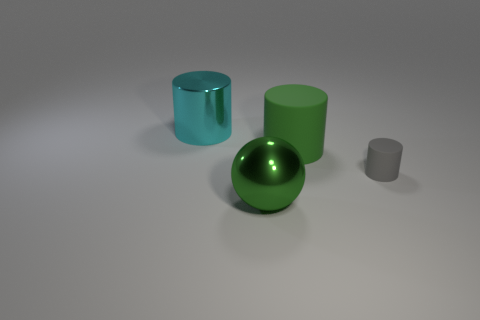Subtract all shiny cylinders. How many cylinders are left? 2 Add 2 big purple cylinders. How many objects exist? 6 Subtract all cylinders. How many objects are left? 1 Add 1 big spheres. How many big spheres are left? 2 Add 3 green balls. How many green balls exist? 4 Subtract 0 brown blocks. How many objects are left? 4 Subtract all purple cylinders. Subtract all green balls. How many cylinders are left? 3 Subtract all green rubber cylinders. Subtract all large cyan metallic cylinders. How many objects are left? 2 